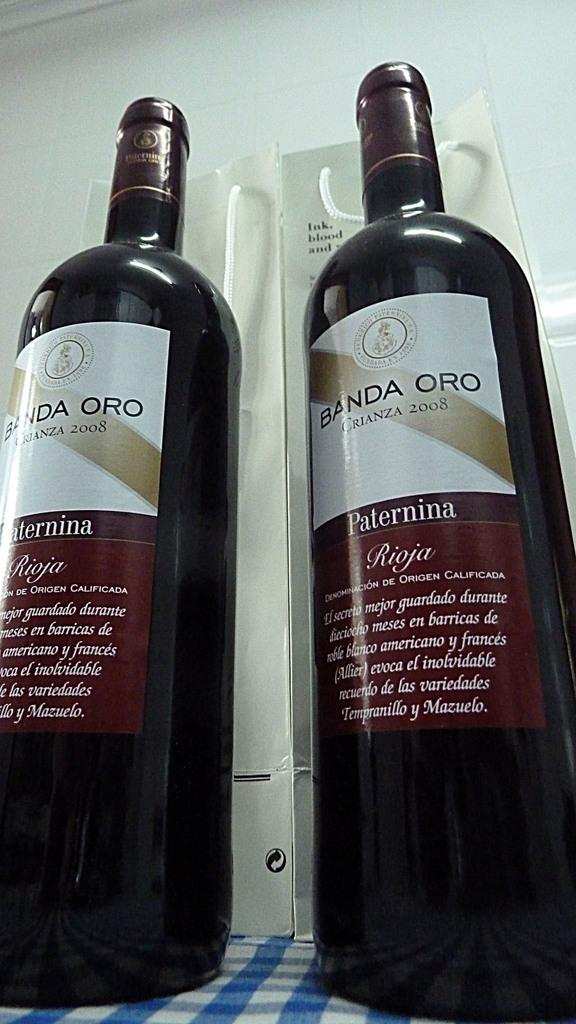<image>
Describe the image concisely. Two bottles side by side and both made in the year 2008. 